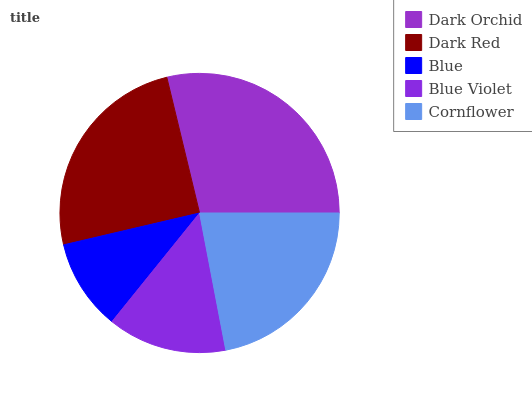Is Blue the minimum?
Answer yes or no. Yes. Is Dark Orchid the maximum?
Answer yes or no. Yes. Is Dark Red the minimum?
Answer yes or no. No. Is Dark Red the maximum?
Answer yes or no. No. Is Dark Orchid greater than Dark Red?
Answer yes or no. Yes. Is Dark Red less than Dark Orchid?
Answer yes or no. Yes. Is Dark Red greater than Dark Orchid?
Answer yes or no. No. Is Dark Orchid less than Dark Red?
Answer yes or no. No. Is Cornflower the high median?
Answer yes or no. Yes. Is Cornflower the low median?
Answer yes or no. Yes. Is Dark Red the high median?
Answer yes or no. No. Is Dark Red the low median?
Answer yes or no. No. 